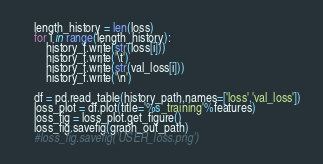Convert code to text. <code><loc_0><loc_0><loc_500><loc_500><_Python_>	length_history = len(loss)
	for i in range(length_history):
		history_f.write(str(loss[i]))
		history_f.write('\t')
		history_f.write(str(val_loss[i]))
		history_f.write('\n')
	
    df = pd.read_table(history_path,names=['loss','val_loss'])
    loss_plot = df.plot(title='%s_training'%features)
    loss_fig = loss_plot.get_figure()
    loss_fig.savefig(graph_out_path)
    #loss_fig.savefig('USER_loss.png')



</code> 